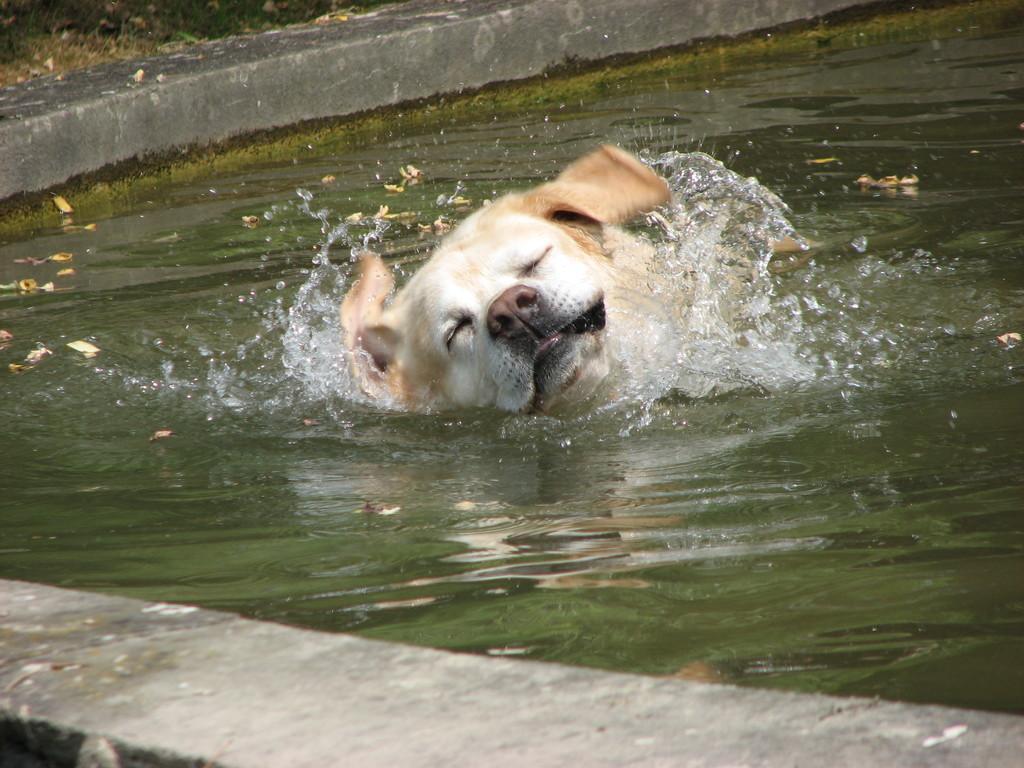Describe this image in one or two sentences. In this picture we can observe a dog swimming in the water. The dog is in cream color. 